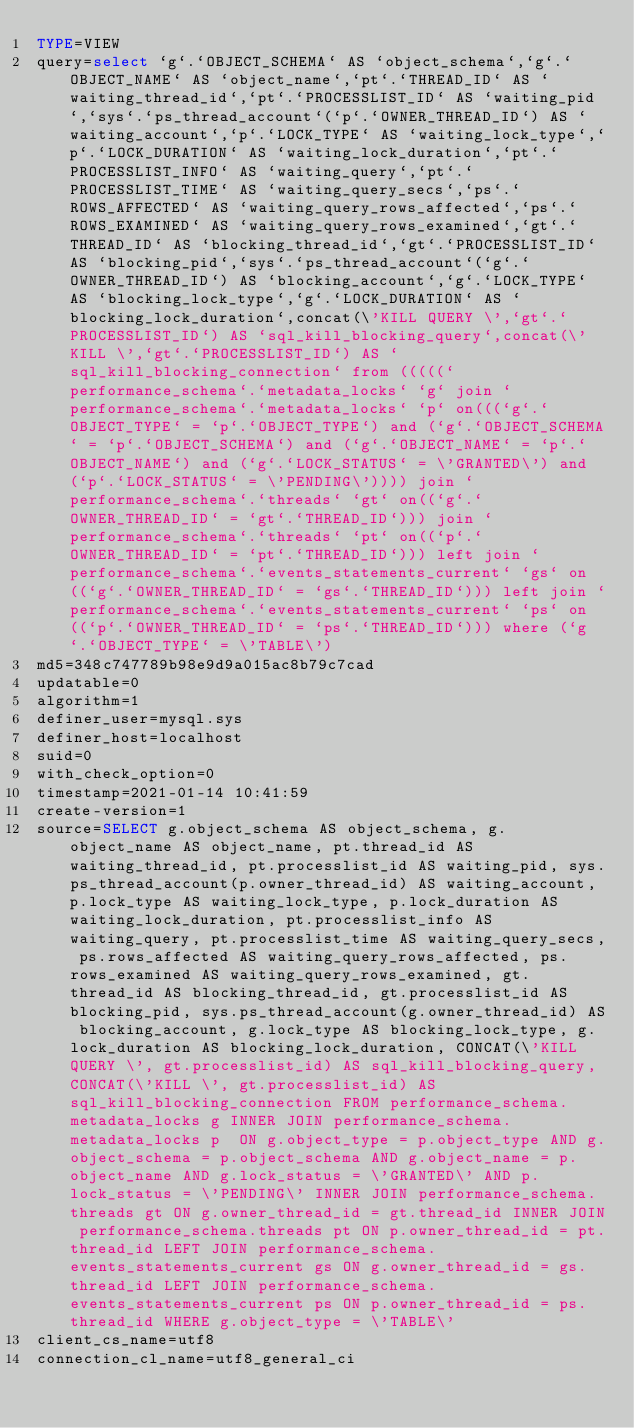<code> <loc_0><loc_0><loc_500><loc_500><_VisualBasic_>TYPE=VIEW
query=select `g`.`OBJECT_SCHEMA` AS `object_schema`,`g`.`OBJECT_NAME` AS `object_name`,`pt`.`THREAD_ID` AS `waiting_thread_id`,`pt`.`PROCESSLIST_ID` AS `waiting_pid`,`sys`.`ps_thread_account`(`p`.`OWNER_THREAD_ID`) AS `waiting_account`,`p`.`LOCK_TYPE` AS `waiting_lock_type`,`p`.`LOCK_DURATION` AS `waiting_lock_duration`,`pt`.`PROCESSLIST_INFO` AS `waiting_query`,`pt`.`PROCESSLIST_TIME` AS `waiting_query_secs`,`ps`.`ROWS_AFFECTED` AS `waiting_query_rows_affected`,`ps`.`ROWS_EXAMINED` AS `waiting_query_rows_examined`,`gt`.`THREAD_ID` AS `blocking_thread_id`,`gt`.`PROCESSLIST_ID` AS `blocking_pid`,`sys`.`ps_thread_account`(`g`.`OWNER_THREAD_ID`) AS `blocking_account`,`g`.`LOCK_TYPE` AS `blocking_lock_type`,`g`.`LOCK_DURATION` AS `blocking_lock_duration`,concat(\'KILL QUERY \',`gt`.`PROCESSLIST_ID`) AS `sql_kill_blocking_query`,concat(\'KILL \',`gt`.`PROCESSLIST_ID`) AS `sql_kill_blocking_connection` from (((((`performance_schema`.`metadata_locks` `g` join `performance_schema`.`metadata_locks` `p` on(((`g`.`OBJECT_TYPE` = `p`.`OBJECT_TYPE`) and (`g`.`OBJECT_SCHEMA` = `p`.`OBJECT_SCHEMA`) and (`g`.`OBJECT_NAME` = `p`.`OBJECT_NAME`) and (`g`.`LOCK_STATUS` = \'GRANTED\') and (`p`.`LOCK_STATUS` = \'PENDING\')))) join `performance_schema`.`threads` `gt` on((`g`.`OWNER_THREAD_ID` = `gt`.`THREAD_ID`))) join `performance_schema`.`threads` `pt` on((`p`.`OWNER_THREAD_ID` = `pt`.`THREAD_ID`))) left join `performance_schema`.`events_statements_current` `gs` on((`g`.`OWNER_THREAD_ID` = `gs`.`THREAD_ID`))) left join `performance_schema`.`events_statements_current` `ps` on((`p`.`OWNER_THREAD_ID` = `ps`.`THREAD_ID`))) where (`g`.`OBJECT_TYPE` = \'TABLE\')
md5=348c747789b98e9d9a015ac8b79c7cad
updatable=0
algorithm=1
definer_user=mysql.sys
definer_host=localhost
suid=0
with_check_option=0
timestamp=2021-01-14 10:41:59
create-version=1
source=SELECT g.object_schema AS object_schema, g.object_name AS object_name, pt.thread_id AS waiting_thread_id, pt.processlist_id AS waiting_pid, sys.ps_thread_account(p.owner_thread_id) AS waiting_account, p.lock_type AS waiting_lock_type, p.lock_duration AS waiting_lock_duration, pt.processlist_info AS waiting_query, pt.processlist_time AS waiting_query_secs, ps.rows_affected AS waiting_query_rows_affected, ps.rows_examined AS waiting_query_rows_examined, gt.thread_id AS blocking_thread_id, gt.processlist_id AS blocking_pid, sys.ps_thread_account(g.owner_thread_id) AS blocking_account, g.lock_type AS blocking_lock_type, g.lock_duration AS blocking_lock_duration, CONCAT(\'KILL QUERY \', gt.processlist_id) AS sql_kill_blocking_query, CONCAT(\'KILL \', gt.processlist_id) AS sql_kill_blocking_connection FROM performance_schema.metadata_locks g INNER JOIN performance_schema.metadata_locks p  ON g.object_type = p.object_type AND g.object_schema = p.object_schema AND g.object_name = p.object_name AND g.lock_status = \'GRANTED\' AND p.lock_status = \'PENDING\' INNER JOIN performance_schema.threads gt ON g.owner_thread_id = gt.thread_id INNER JOIN performance_schema.threads pt ON p.owner_thread_id = pt.thread_id LEFT JOIN performance_schema.events_statements_current gs ON g.owner_thread_id = gs.thread_id LEFT JOIN performance_schema.events_statements_current ps ON p.owner_thread_id = ps.thread_id WHERE g.object_type = \'TABLE\'
client_cs_name=utf8
connection_cl_name=utf8_general_ci</code> 